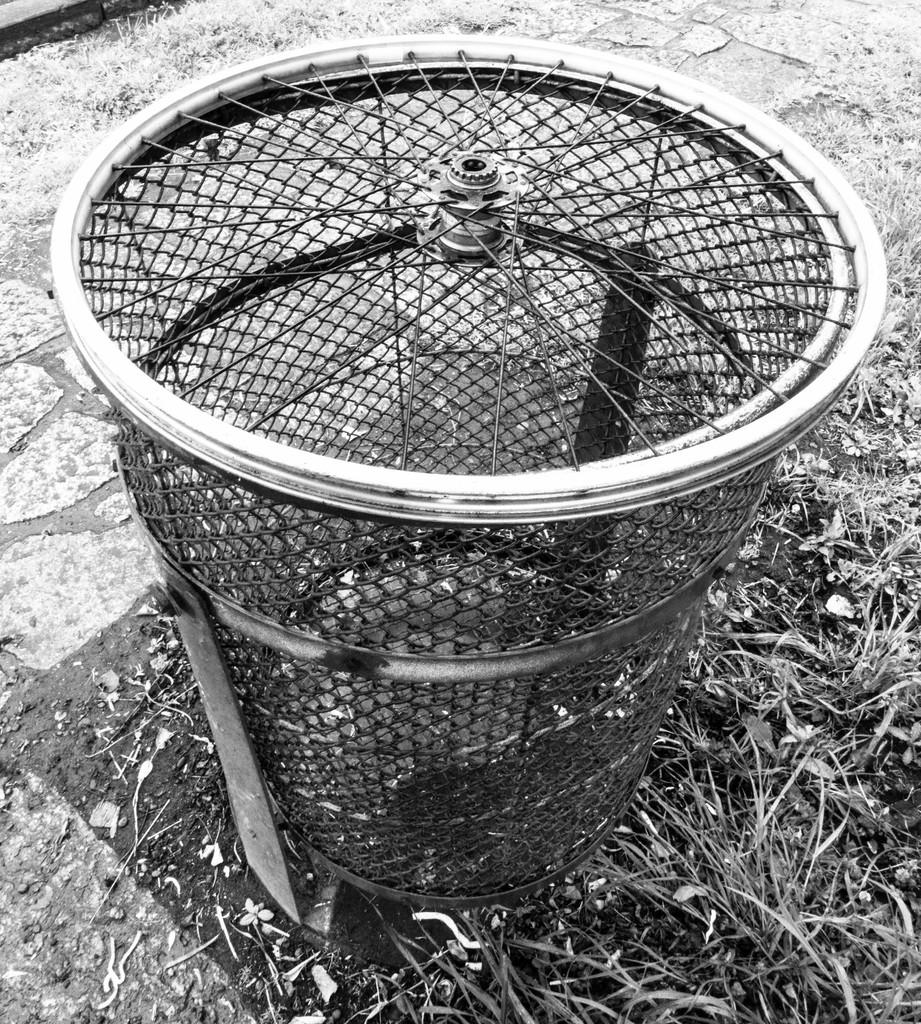What type of fence can be seen in the foreground of the image? There is a wheel fence in the foreground of the image. What is covering the ground in the image? Grass is present on the ground. When was the image taken? The image was taken during the day. What type of credit card is being used to purchase the wheel fence in the image? There is no credit card or purchase being depicted in the image; it simply shows a wheel fence and grass. 